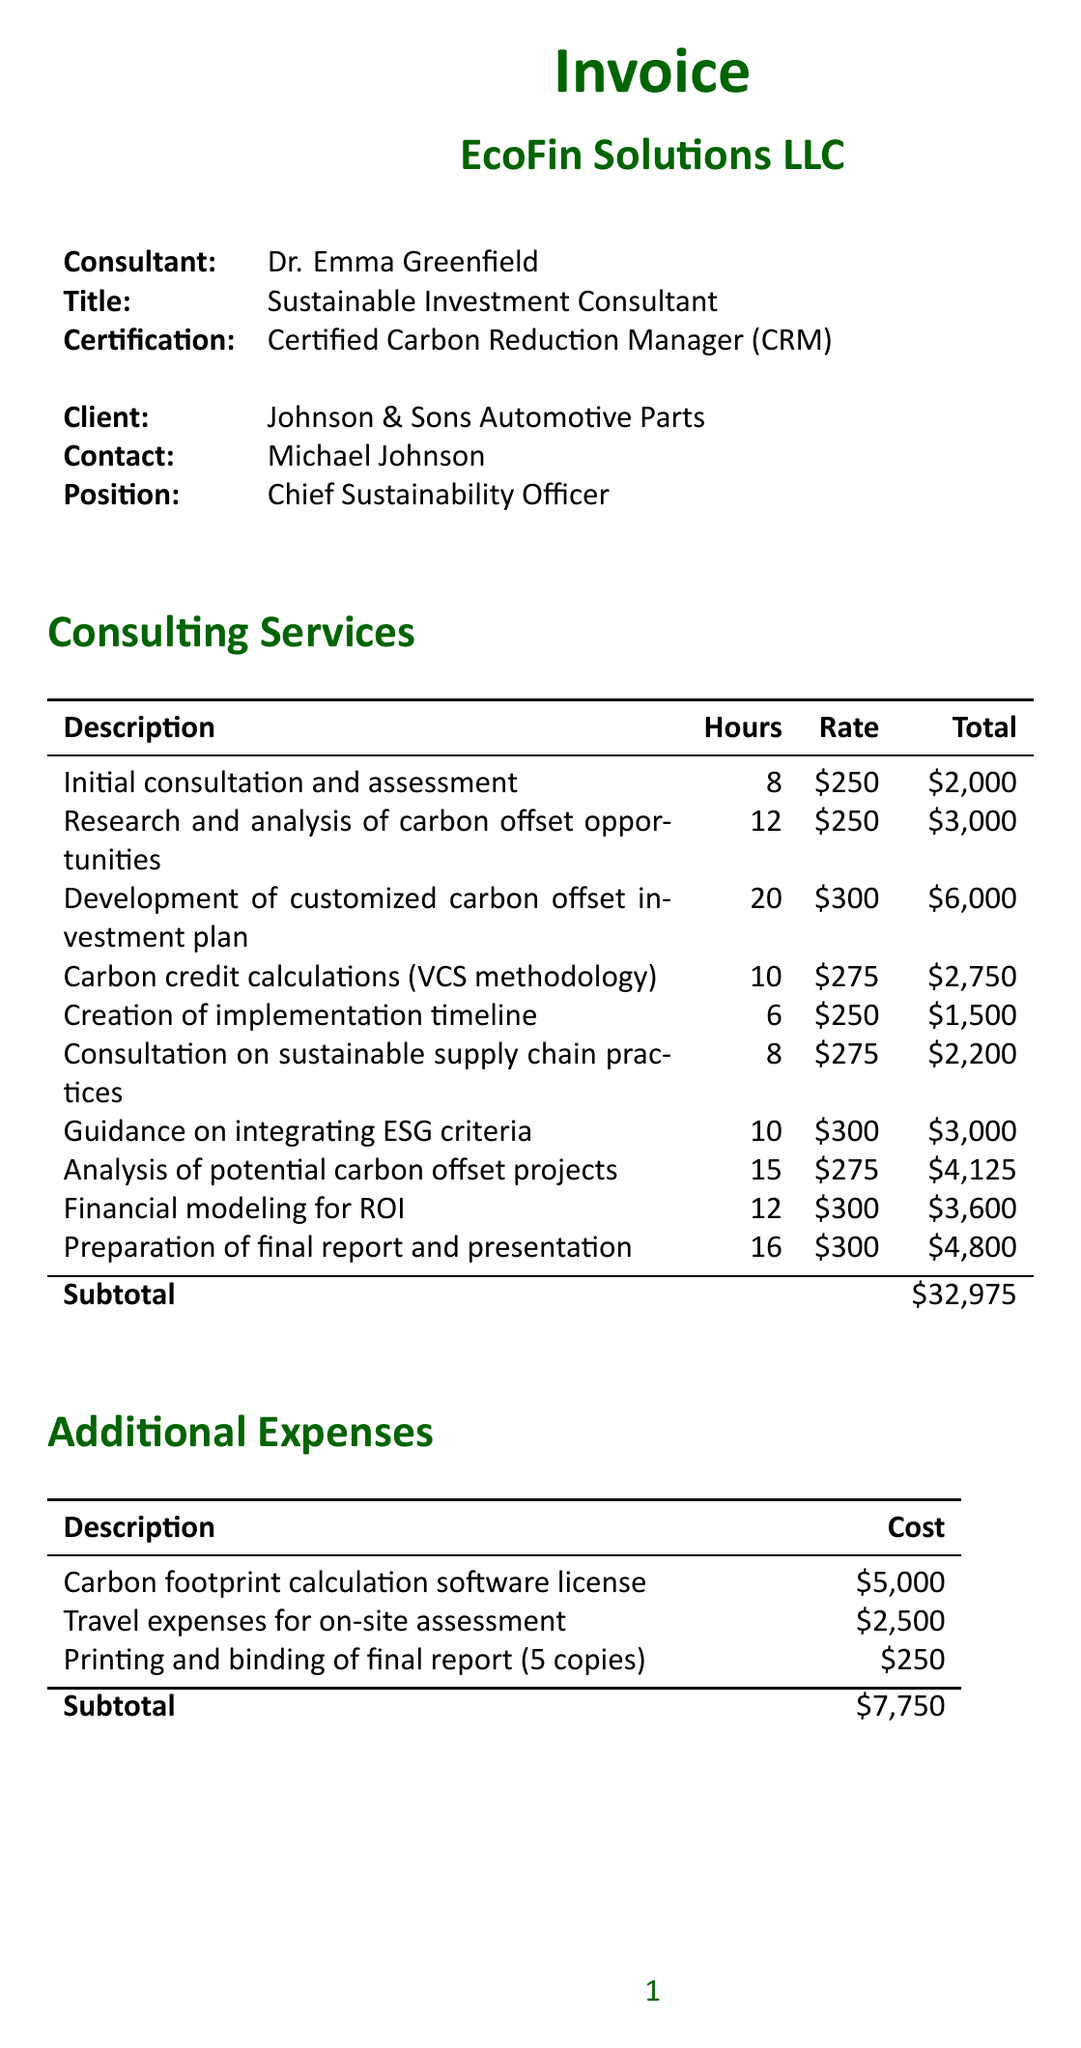What is the total due amount? The total due is the sum of consulting services and additional expenses, which is $32,975 + $7,750 = $40,725.
Answer: $40,725 Who is the consultant's name? The consultant's name is listed at the top of the document, under the consultant details.
Answer: Dr. Emma Greenfield How many hours were spent on developing the carbon offset investment plan? The number of hours for developing the investment plan is specified in the consulting services section.
Answer: 20 What is the cost of the carbon footprint calculation software license? The cost for the software license is detailed under additional expenses.
Answer: $5,000 What is the late fee percentage for unpaid balances? The late fee percentage is stated in the payment terms section of the document.
Answer: 1.5% What was the purpose of the consultation on sustainable supply chain practices? This description can be found in the consulting services section and specifies the area of focus for that consultation.
Answer: Sustainable supply chain practices What method was used for carbon credit calculations? The method for carbon credit calculations is mentioned in the consulting services section.
Answer: VCS (Verified Carbon Standard) methodology How many copies of the final report were printed and bound? The number of printed copies of the final report is specified in the additional expenses section.
Answer: 5 copies 